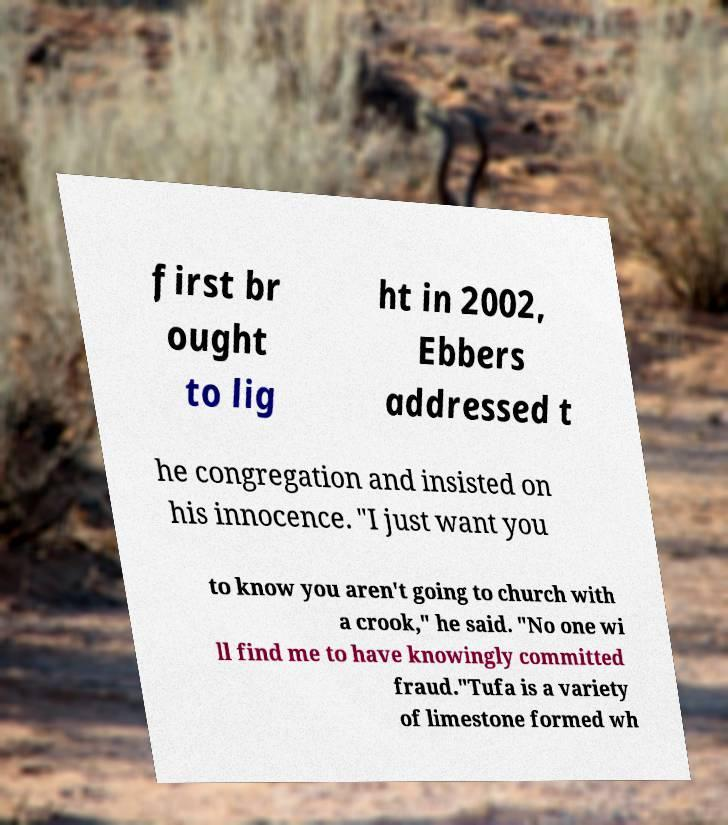There's text embedded in this image that I need extracted. Can you transcribe it verbatim? first br ought to lig ht in 2002, Ebbers addressed t he congregation and insisted on his innocence. "I just want you to know you aren't going to church with a crook," he said. "No one wi ll find me to have knowingly committed fraud."Tufa is a variety of limestone formed wh 